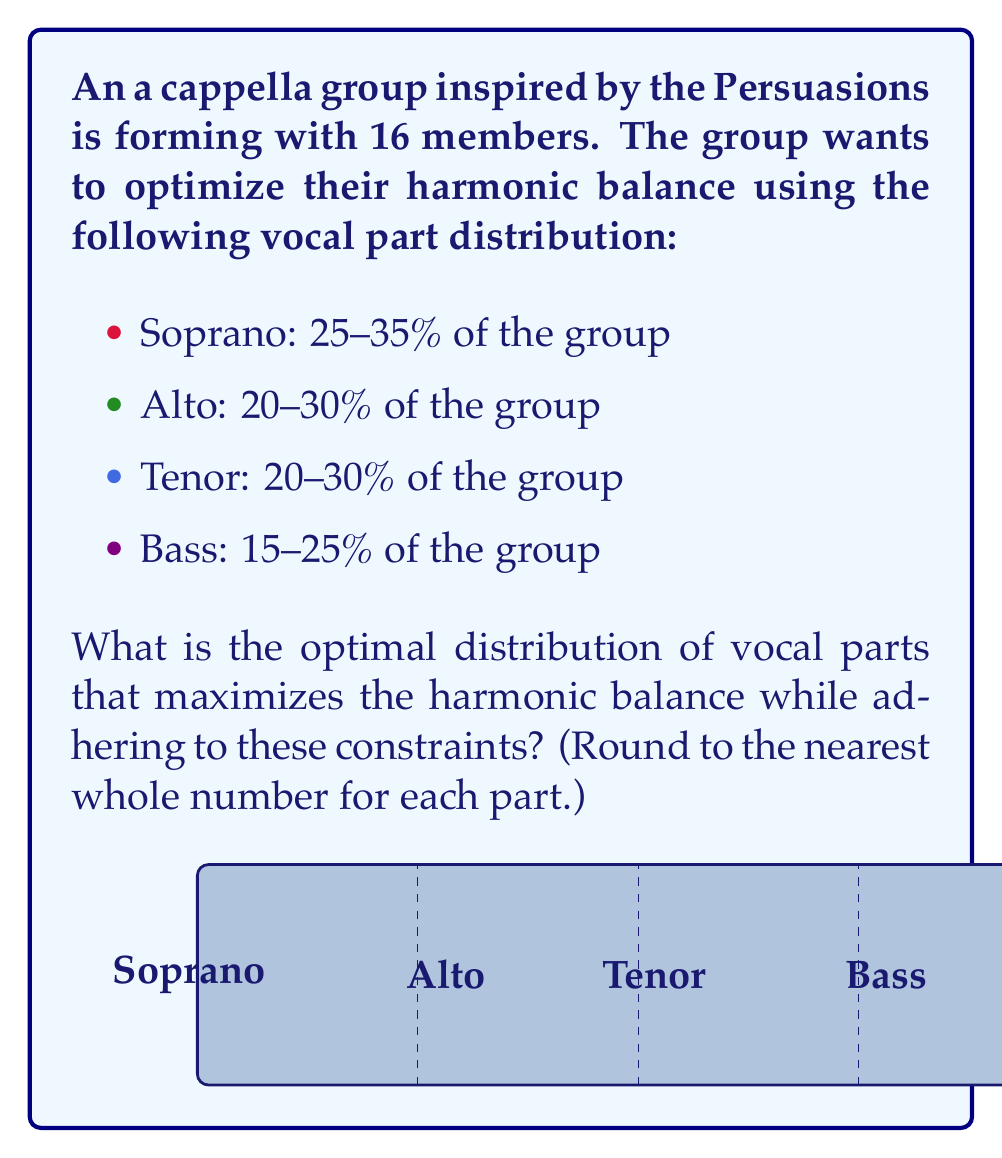Solve this math problem. To optimize the distribution of vocal parts, we need to maximize the number of singers in each part while adhering to the given constraints. Let's approach this step-by-step:

1. Define variables:
   Let $s$, $a$, $t$, and $b$ represent the number of sopranos, altos, tenors, and basses respectively.

2. Set up constraints:
   Total members: $s + a + t + b = 16$
   Soprano: $0.25 \cdot 16 \leq s \leq 0.35 \cdot 16$, i.e., $4 \leq s \leq 5.6$
   Alto: $0.20 \cdot 16 \leq a \leq 0.30 \cdot 16$, i.e., $3.2 \leq a \leq 4.8$
   Tenor: $0.20 \cdot 16 \leq t \leq 0.30 \cdot 16$, i.e., $3.2 \leq t \leq 4.8$
   Bass: $0.15 \cdot 16 \leq b \leq 0.25 \cdot 16$, i.e., $2.4 \leq b \leq 4$

3. Optimize:
   To maximize harmonic balance, we want to distribute the singers as evenly as possible while staying within the constraints.

   Soprano: Maximum 5 (rounded down from 5.6)
   Alto: Maximum 4 (rounded down from 4.8)
   Tenor: Maximum 4 (rounded down from 4.8)
   Bass: 3 (to make the total 16)

4. Verify:
   $5 + 4 + 4 + 3 = 16$ (total constraint satisfied)
   Soprano: $5/16 = 31.25\%$ (within 25-35%)
   Alto: $4/16 = 25\%$ (within 20-30%)
   Tenor: $4/16 = 25\%$ (within 20-30%)
   Bass: $3/16 = 18.75\%$ (within 15-25%)

This distribution maximizes the number of singers in each part while adhering to the given constraints and ensures the most balanced harmonic distribution possible.
Answer: Soprano: 5, Alto: 4, Tenor: 4, Bass: 3 